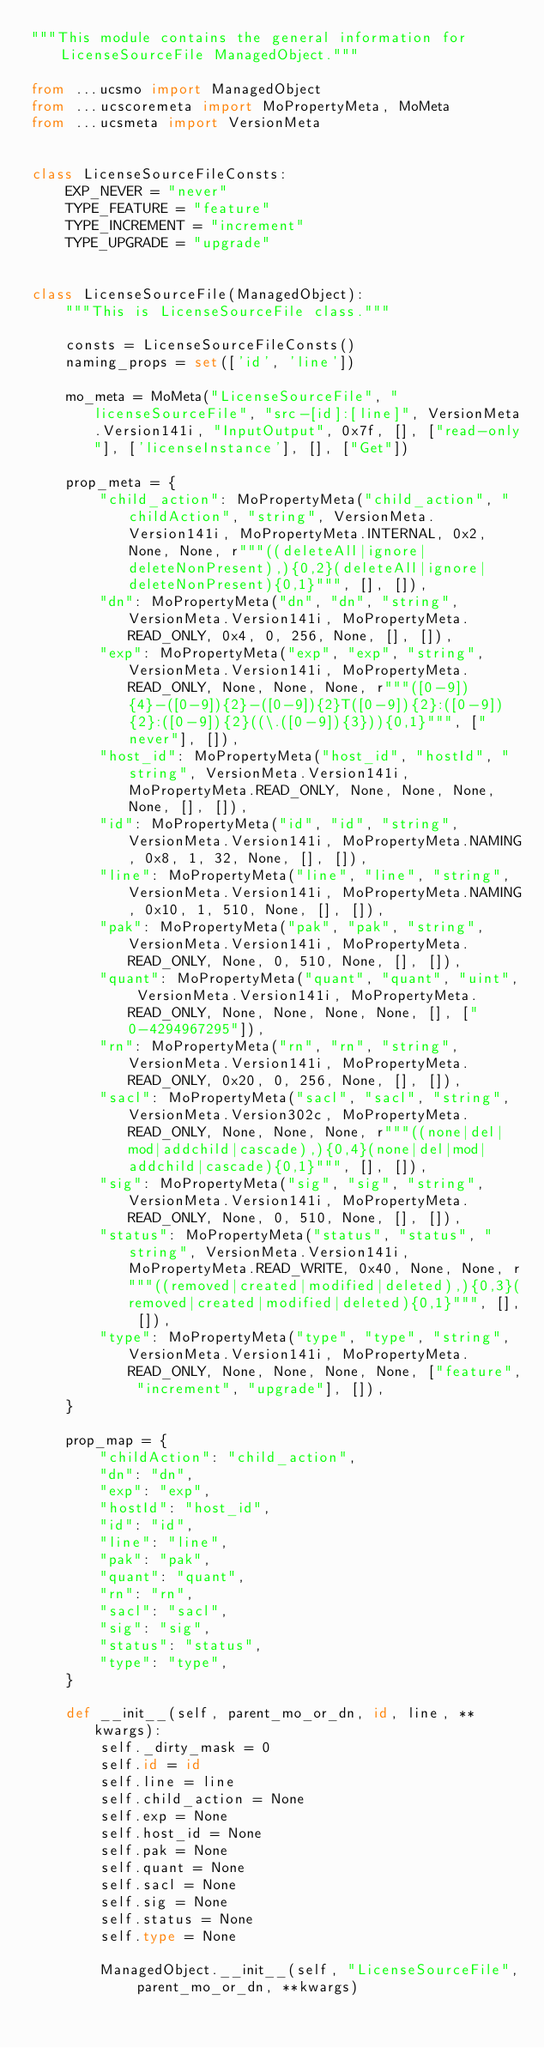<code> <loc_0><loc_0><loc_500><loc_500><_Python_>"""This module contains the general information for LicenseSourceFile ManagedObject."""

from ...ucsmo import ManagedObject
from ...ucscoremeta import MoPropertyMeta, MoMeta
from ...ucsmeta import VersionMeta


class LicenseSourceFileConsts:
    EXP_NEVER = "never"
    TYPE_FEATURE = "feature"
    TYPE_INCREMENT = "increment"
    TYPE_UPGRADE = "upgrade"


class LicenseSourceFile(ManagedObject):
    """This is LicenseSourceFile class."""

    consts = LicenseSourceFileConsts()
    naming_props = set(['id', 'line'])

    mo_meta = MoMeta("LicenseSourceFile", "licenseSourceFile", "src-[id]:[line]", VersionMeta.Version141i, "InputOutput", 0x7f, [], ["read-only"], ['licenseInstance'], [], ["Get"])

    prop_meta = {
        "child_action": MoPropertyMeta("child_action", "childAction", "string", VersionMeta.Version141i, MoPropertyMeta.INTERNAL, 0x2, None, None, r"""((deleteAll|ignore|deleteNonPresent),){0,2}(deleteAll|ignore|deleteNonPresent){0,1}""", [], []),
        "dn": MoPropertyMeta("dn", "dn", "string", VersionMeta.Version141i, MoPropertyMeta.READ_ONLY, 0x4, 0, 256, None, [], []),
        "exp": MoPropertyMeta("exp", "exp", "string", VersionMeta.Version141i, MoPropertyMeta.READ_ONLY, None, None, None, r"""([0-9]){4}-([0-9]){2}-([0-9]){2}T([0-9]){2}:([0-9]){2}:([0-9]){2}((\.([0-9]){3})){0,1}""", ["never"], []),
        "host_id": MoPropertyMeta("host_id", "hostId", "string", VersionMeta.Version141i, MoPropertyMeta.READ_ONLY, None, None, None, None, [], []),
        "id": MoPropertyMeta("id", "id", "string", VersionMeta.Version141i, MoPropertyMeta.NAMING, 0x8, 1, 32, None, [], []),
        "line": MoPropertyMeta("line", "line", "string", VersionMeta.Version141i, MoPropertyMeta.NAMING, 0x10, 1, 510, None, [], []),
        "pak": MoPropertyMeta("pak", "pak", "string", VersionMeta.Version141i, MoPropertyMeta.READ_ONLY, None, 0, 510, None, [], []),
        "quant": MoPropertyMeta("quant", "quant", "uint", VersionMeta.Version141i, MoPropertyMeta.READ_ONLY, None, None, None, None, [], ["0-4294967295"]),
        "rn": MoPropertyMeta("rn", "rn", "string", VersionMeta.Version141i, MoPropertyMeta.READ_ONLY, 0x20, 0, 256, None, [], []),
        "sacl": MoPropertyMeta("sacl", "sacl", "string", VersionMeta.Version302c, MoPropertyMeta.READ_ONLY, None, None, None, r"""((none|del|mod|addchild|cascade),){0,4}(none|del|mod|addchild|cascade){0,1}""", [], []),
        "sig": MoPropertyMeta("sig", "sig", "string", VersionMeta.Version141i, MoPropertyMeta.READ_ONLY, None, 0, 510, None, [], []),
        "status": MoPropertyMeta("status", "status", "string", VersionMeta.Version141i, MoPropertyMeta.READ_WRITE, 0x40, None, None, r"""((removed|created|modified|deleted),){0,3}(removed|created|modified|deleted){0,1}""", [], []),
        "type": MoPropertyMeta("type", "type", "string", VersionMeta.Version141i, MoPropertyMeta.READ_ONLY, None, None, None, None, ["feature", "increment", "upgrade"], []),
    }

    prop_map = {
        "childAction": "child_action", 
        "dn": "dn", 
        "exp": "exp", 
        "hostId": "host_id", 
        "id": "id", 
        "line": "line", 
        "pak": "pak", 
        "quant": "quant", 
        "rn": "rn", 
        "sacl": "sacl", 
        "sig": "sig", 
        "status": "status", 
        "type": "type", 
    }

    def __init__(self, parent_mo_or_dn, id, line, **kwargs):
        self._dirty_mask = 0
        self.id = id
        self.line = line
        self.child_action = None
        self.exp = None
        self.host_id = None
        self.pak = None
        self.quant = None
        self.sacl = None
        self.sig = None
        self.status = None
        self.type = None

        ManagedObject.__init__(self, "LicenseSourceFile", parent_mo_or_dn, **kwargs)
</code> 